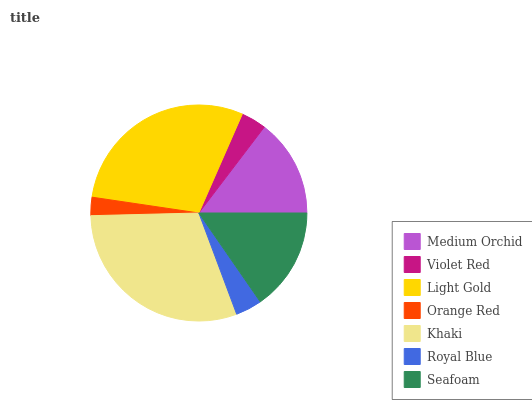Is Orange Red the minimum?
Answer yes or no. Yes. Is Khaki the maximum?
Answer yes or no. Yes. Is Violet Red the minimum?
Answer yes or no. No. Is Violet Red the maximum?
Answer yes or no. No. Is Medium Orchid greater than Violet Red?
Answer yes or no. Yes. Is Violet Red less than Medium Orchid?
Answer yes or no. Yes. Is Violet Red greater than Medium Orchid?
Answer yes or no. No. Is Medium Orchid less than Violet Red?
Answer yes or no. No. Is Medium Orchid the high median?
Answer yes or no. Yes. Is Medium Orchid the low median?
Answer yes or no. Yes. Is Seafoam the high median?
Answer yes or no. No. Is Light Gold the low median?
Answer yes or no. No. 